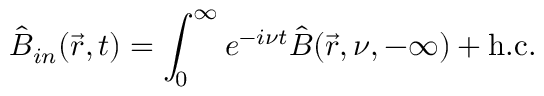<formula> <loc_0><loc_0><loc_500><loc_500>\hat { B } _ { i n } ( \vec { r } , t ) = \int _ { 0 } ^ { \infty } e ^ { - i \nu t } \hat { B } ( \vec { r } , \nu , - \infty ) + h . c .</formula> 